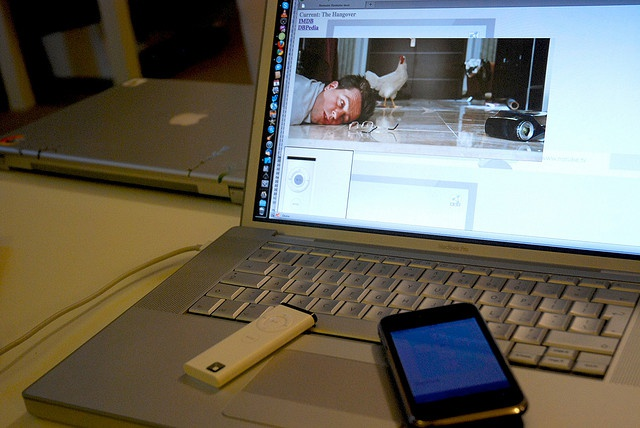Describe the objects in this image and their specific colors. I can see laptop in black, lightblue, and gray tones, cell phone in black, navy, darkblue, and maroon tones, remote in black, tan, and olive tones, and people in black, darkgray, and brown tones in this image. 